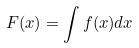Convert formula to latex. <formula><loc_0><loc_0><loc_500><loc_500>F ( x ) = \int f ( x ) d x</formula> 